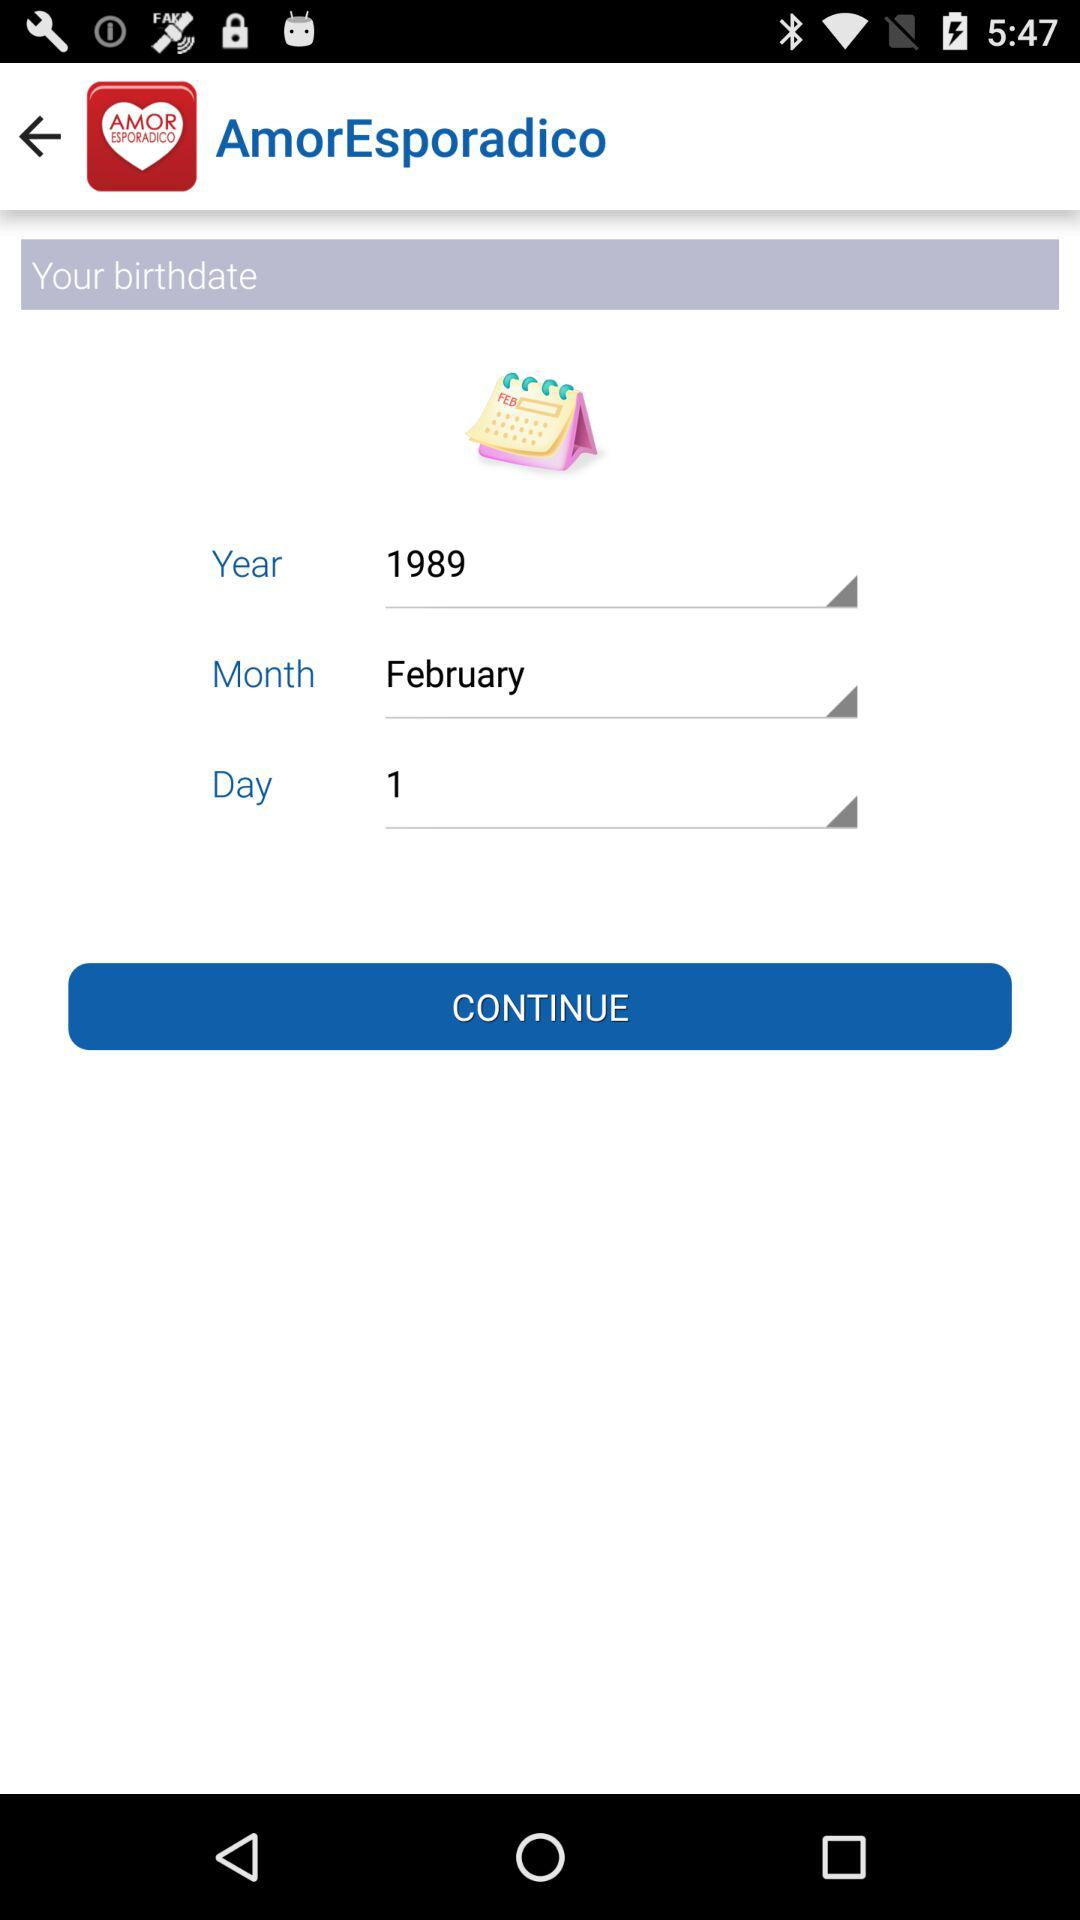Which is the month of birth? The month of birth is February. 